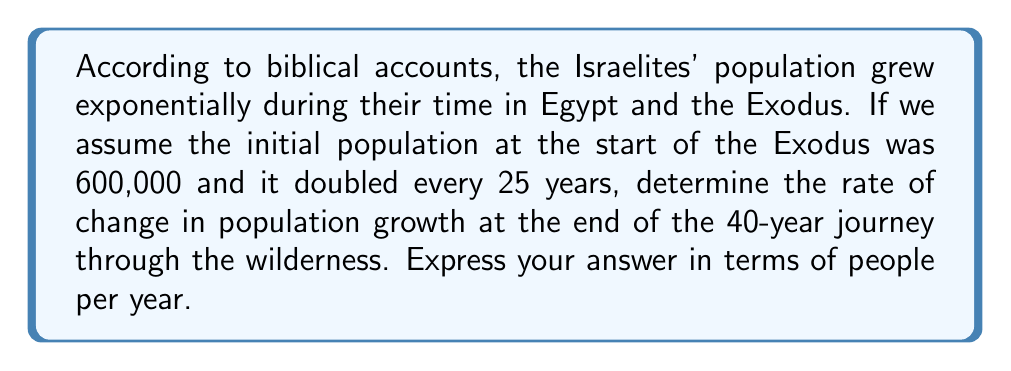Help me with this question. Let's approach this problem step-by-step using differential equations:

1) First, we need to set up our exponential growth model. The general form is:

   $$P(t) = P_0 e^{rt}$$

   Where $P(t)$ is the population at time $t$, $P_0$ is the initial population, $r$ is the growth rate, and $t$ is time.

2) We're given that the population doubles every 25 years. We can use this to find $r$:

   $$2 = e^{25r}$$
   $$\ln(2) = 25r$$
   $$r = \frac{\ln(2)}{25} \approx 0.0277$$

3) Now we have our full equation:

   $$P(t) = 600000 e^{0.0277t}$$

4) To find the rate of change, we need to differentiate this equation with respect to $t$:

   $$\frac{dP}{dt} = 600000 \cdot 0.0277 e^{0.0277t}$$

5) We want to know the rate of change at the end of the 40-year journey, so we plug in $t = 40$:

   $$\frac{dP}{dt}\bigg|_{t=40} = 600000 \cdot 0.0277 e^{0.0277 \cdot 40}$$

6) Let's calculate this:

   $$\frac{dP}{dt}\bigg|_{t=40} = 600000 \cdot 0.0277 \cdot e^{1.108} \approx 54,117$$

Therefore, at the end of the 40-year Exodus, the population was growing at a rate of approximately 54,117 people per year.
Answer: 54,117 people/year 